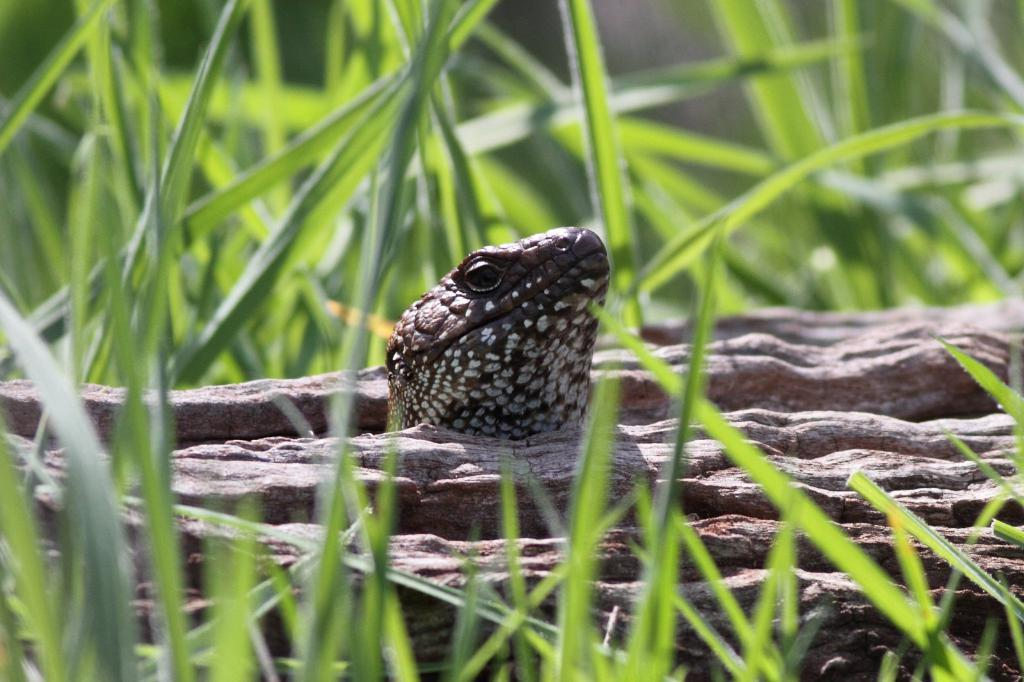What is the main subject in the center of the image? There is a snake in the center of the image. What can be seen in the foreground of the image? There are plants in the foreground of the image. What can be seen in the background of the image? There are plants in the background of the image. How many frogs are sitting on the snake in the image? There are no frogs present in the image; it only features a snake and plants. What type of leather can be seen in the image? There is no leather present in the image. 